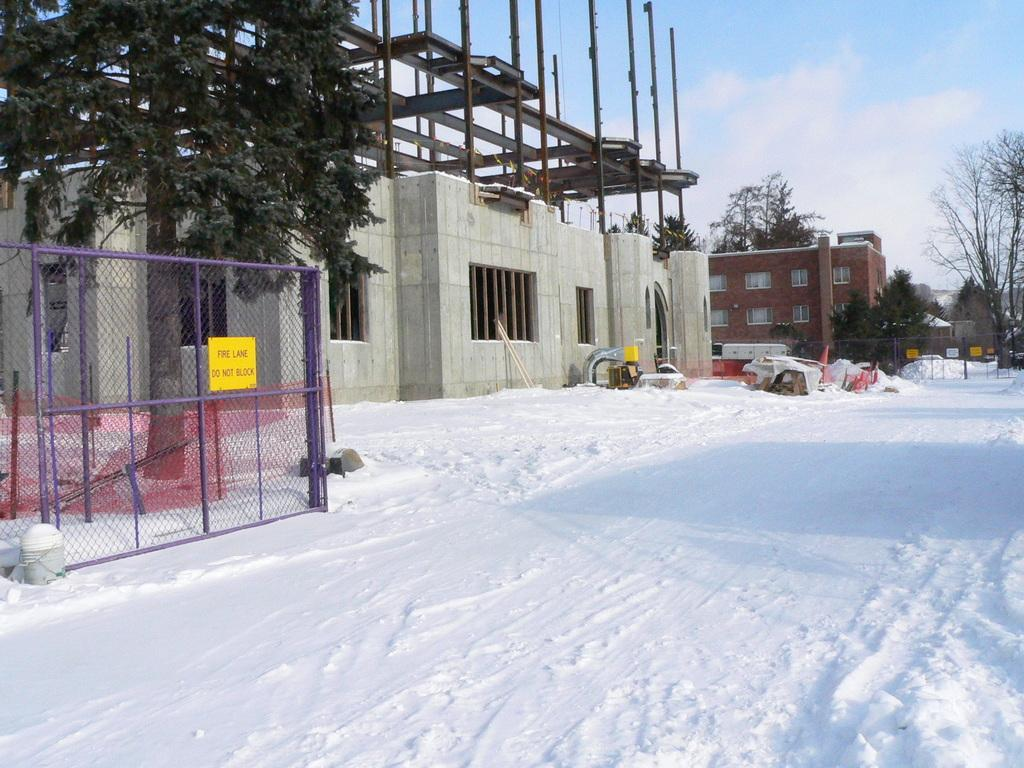What is the condition of the land in the image? The land in the image is covered with snow. What can be seen in the background of the image? There are buildings, trees, fencing, and the sky visible in the background of the image. Can you see a goat or a tiger in the image? No, there are no goats or tigers present in the image. What does the image need to be complete? The image is already complete as it is, and no additional elements are needed. 